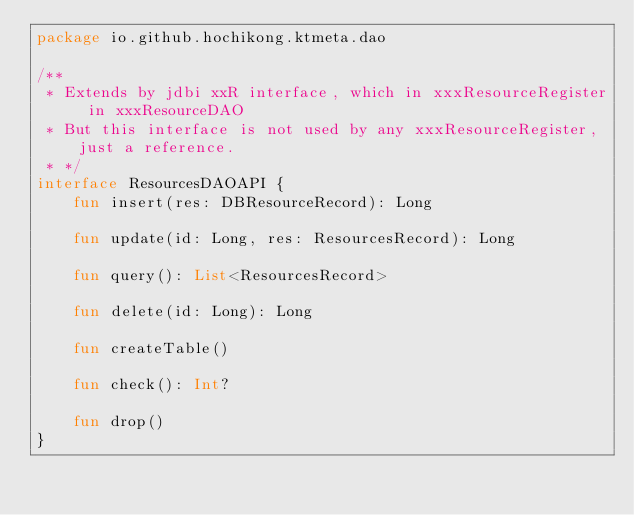Convert code to text. <code><loc_0><loc_0><loc_500><loc_500><_Kotlin_>package io.github.hochikong.ktmeta.dao

/**
 * Extends by jdbi xxR interface, which in xxxResourceRegister in xxxResourceDAO
 * But this interface is not used by any xxxResourceRegister, just a reference.
 * */
interface ResourcesDAOAPI {
    fun insert(res: DBResourceRecord): Long

    fun update(id: Long, res: ResourcesRecord): Long

    fun query(): List<ResourcesRecord>

    fun delete(id: Long): Long

    fun createTable()

    fun check(): Int?

    fun drop()
}</code> 